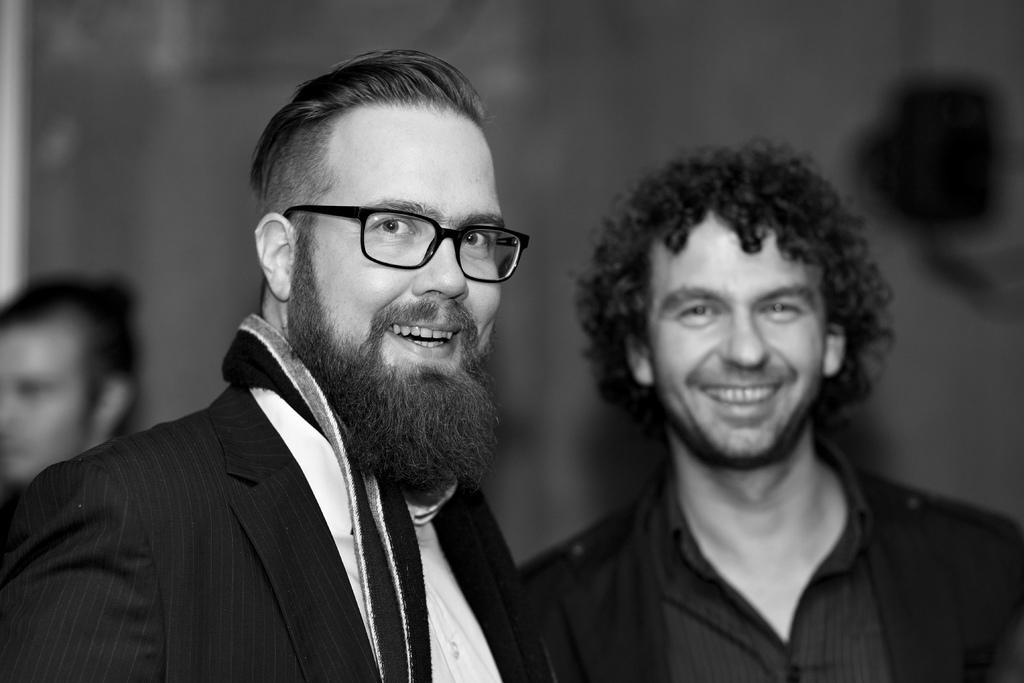Please provide a concise description of this image. In the image two persons are standing and smiling. Behind them a person is standing. Background of the image is blur. 